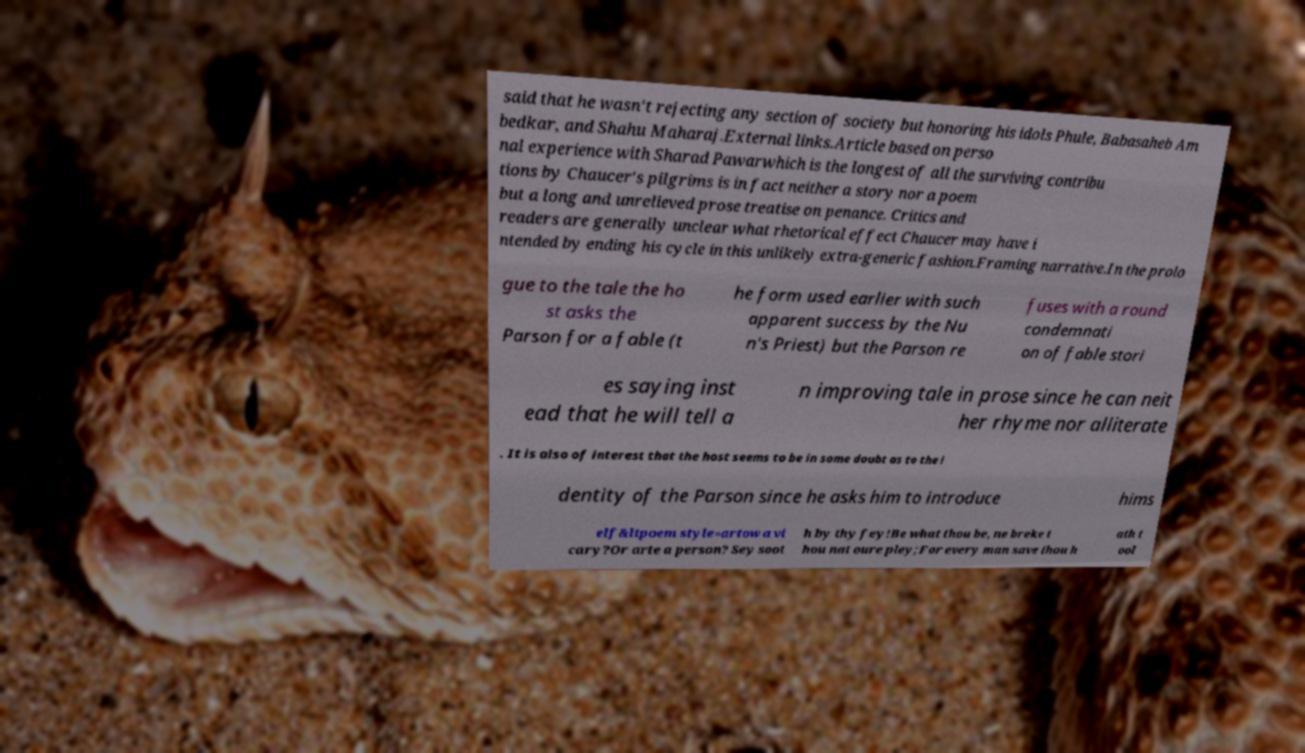Could you extract and type out the text from this image? said that he wasn't rejecting any section of society but honoring his idols Phule, Babasaheb Am bedkar, and Shahu Maharaj.External links.Article based on perso nal experience with Sharad Pawarwhich is the longest of all the surviving contribu tions by Chaucer's pilgrims is in fact neither a story nor a poem but a long and unrelieved prose treatise on penance. Critics and readers are generally unclear what rhetorical effect Chaucer may have i ntended by ending his cycle in this unlikely extra-generic fashion.Framing narrative.In the prolo gue to the tale the ho st asks the Parson for a fable (t he form used earlier with such apparent success by the Nu n's Priest) but the Parson re fuses with a round condemnati on of fable stori es saying inst ead that he will tell a n improving tale in prose since he can neit her rhyme nor alliterate . It is also of interest that the host seems to be in some doubt as to the i dentity of the Parson since he asks him to introduce hims elf&ltpoem style=artow a vi cary?Or arte a person? Sey soot h by thy fey!Be what thou be, ne breke t hou nat oure pley;For every man save thou h ath t ool 